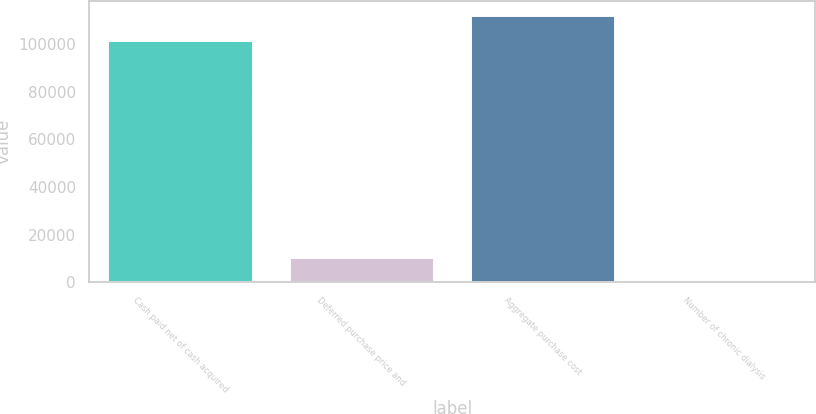Convert chart to OTSL. <chart><loc_0><loc_0><loc_500><loc_500><bar_chart><fcel>Cash paid net of cash acquired<fcel>Deferred purchase price and<fcel>Aggregate purchase cost<fcel>Number of chronic dialysis<nl><fcel>101959<fcel>10442.5<fcel>112382<fcel>20<nl></chart> 